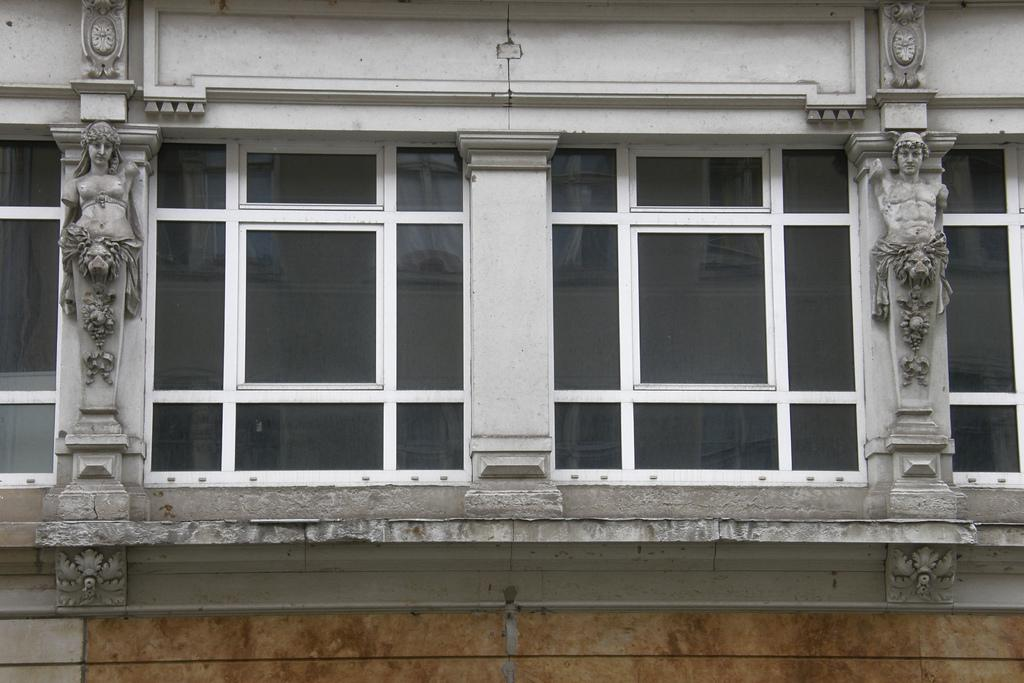What type of structure is present in the image? There is a building in the image. What artistic elements can be seen in the image? There are sculptures in the image. What type of material is used for the windows in the building? There are glass windows in the center of the image. How does the sky contribute to the balance of the sculptures in the image? The sky is not a part of the sculptures in the image, and therefore it does not contribute to their balance. 